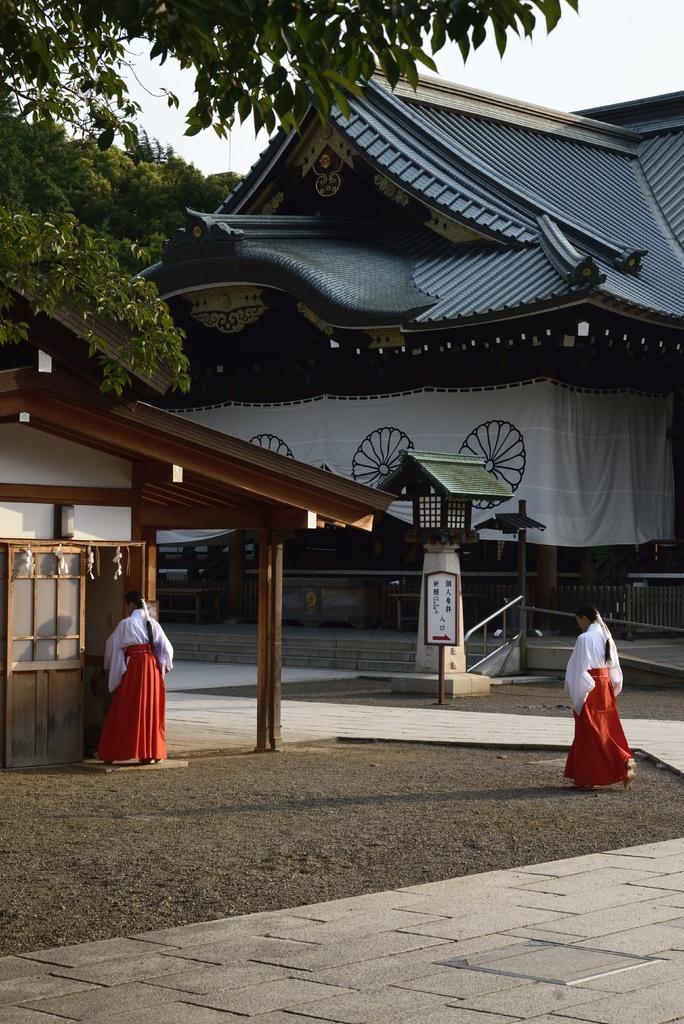Please provide a concise description of this image. In the center of the image we can see a house and a cloth are present. On the left side of the image a tree and a lady are there. At the bottom of the image ground is present. In the middle of the image a sign board is there. At the top of the image sky is present. 